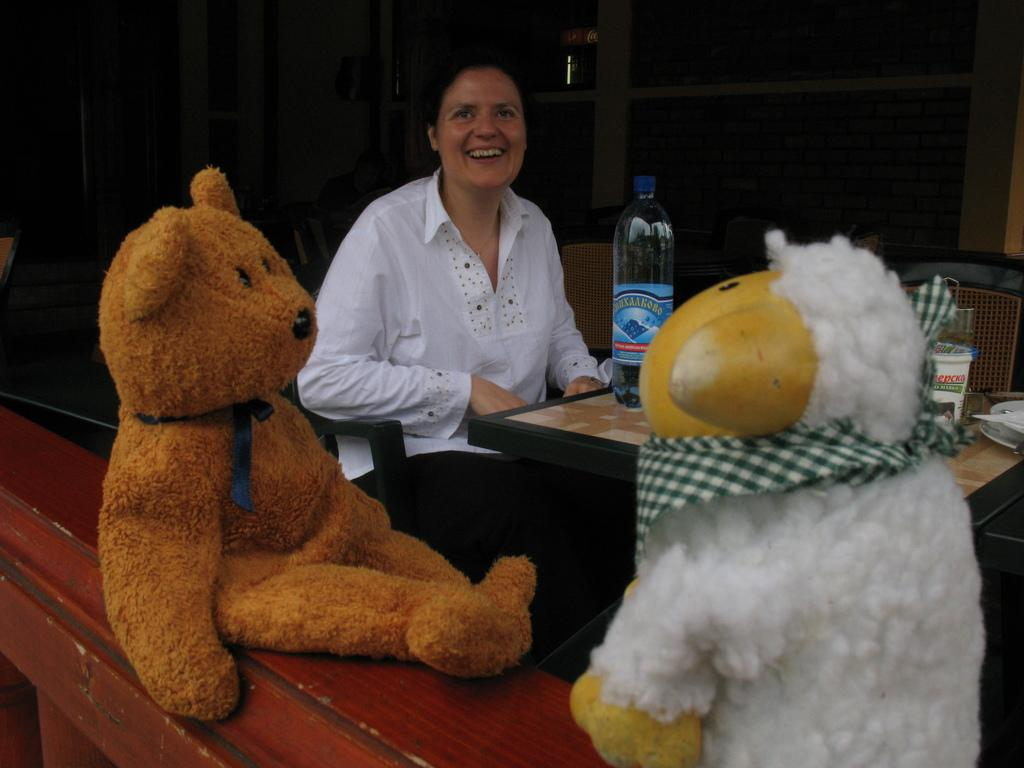Who is the main subject in the picture? There is a woman in the picture. What is the woman doing in the image? The woman is sitting on a chair. Where is the woman located in the image? The woman is in the middle of the picture. What expression does the woman have? The woman is smiling. What objects are in front of the woman? There are two teddy bears in front of her. What is the color of the background in the image? The background of the image is dark. How many trucks can be seen in the image? There are no trucks present in the image. What type of water is visible in the image? There is no water visible in the image. 